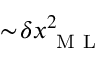Convert formula to latex. <formula><loc_0><loc_0><loc_500><loc_500>\sim \, \delta x _ { M L } ^ { 2 }</formula> 